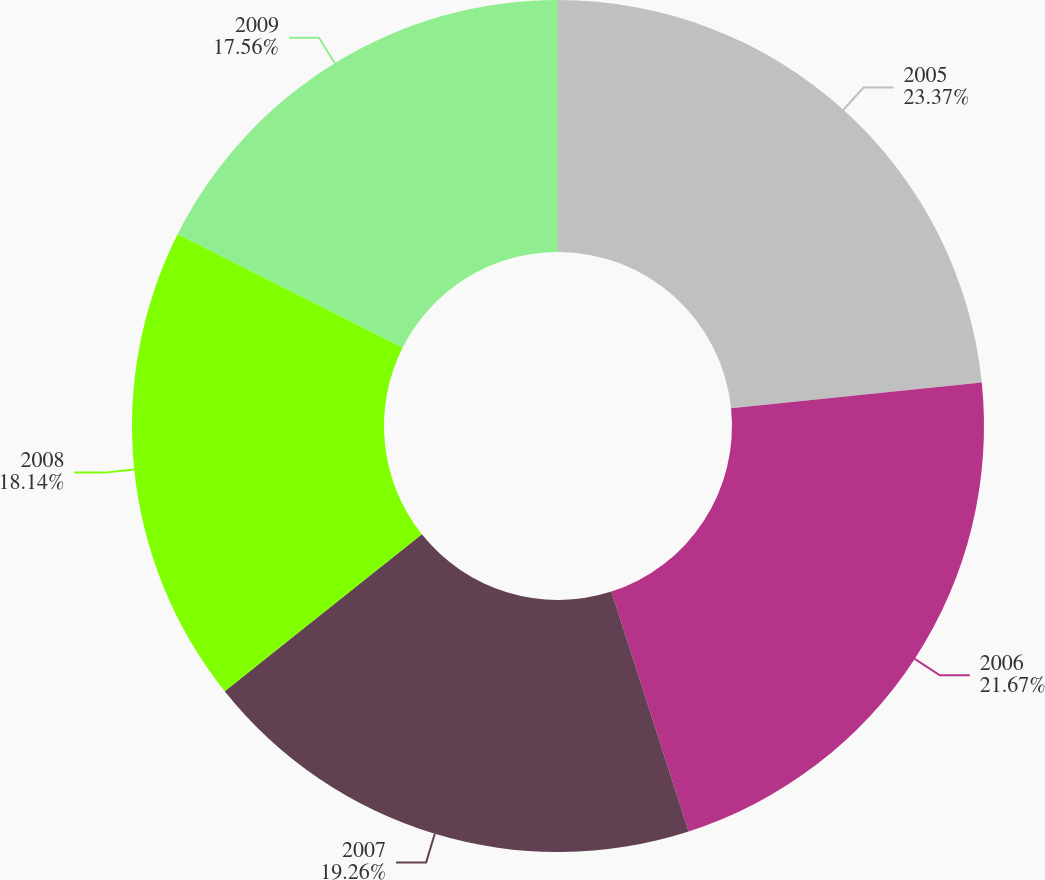<chart> <loc_0><loc_0><loc_500><loc_500><pie_chart><fcel>2005<fcel>2006<fcel>2007<fcel>2008<fcel>2009<nl><fcel>23.37%<fcel>21.67%<fcel>19.26%<fcel>18.14%<fcel>17.56%<nl></chart> 